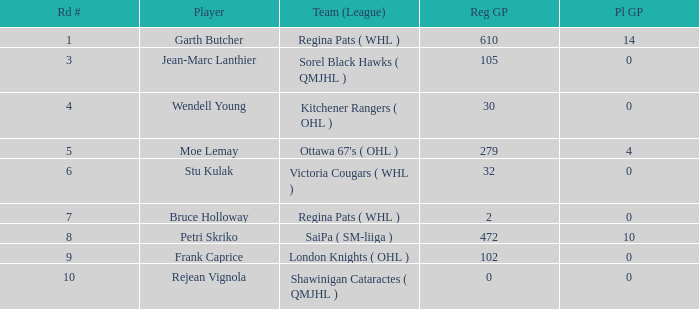What is the aggregate amount of pl gp when the chosen number is 178 and the pathway number exceeds 9? 0.0. 